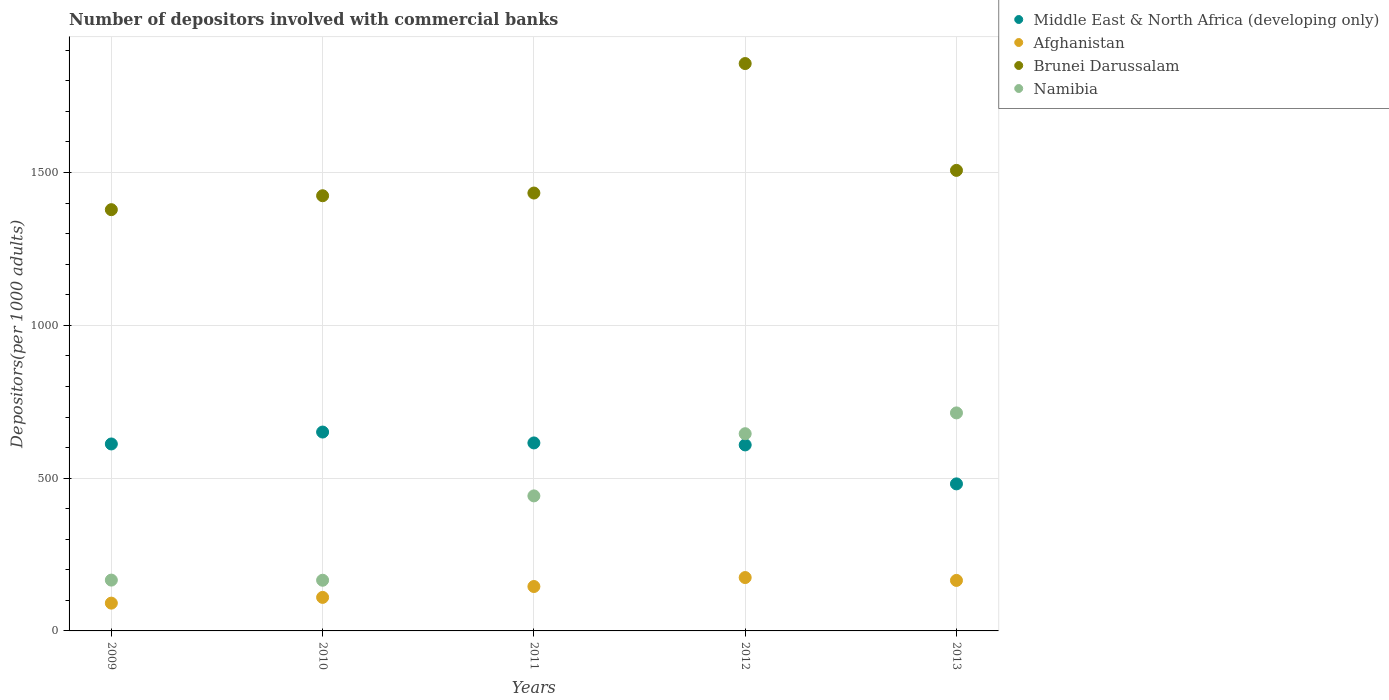How many different coloured dotlines are there?
Offer a very short reply. 4. Is the number of dotlines equal to the number of legend labels?
Ensure brevity in your answer.  Yes. What is the number of depositors involved with commercial banks in Middle East & North Africa (developing only) in 2009?
Your response must be concise. 611.77. Across all years, what is the maximum number of depositors involved with commercial banks in Namibia?
Ensure brevity in your answer.  713.41. Across all years, what is the minimum number of depositors involved with commercial banks in Namibia?
Offer a very short reply. 165.83. In which year was the number of depositors involved with commercial banks in Middle East & North Africa (developing only) maximum?
Offer a terse response. 2010. In which year was the number of depositors involved with commercial banks in Brunei Darussalam minimum?
Give a very brief answer. 2009. What is the total number of depositors involved with commercial banks in Namibia in the graph?
Ensure brevity in your answer.  2132.7. What is the difference between the number of depositors involved with commercial banks in Namibia in 2009 and that in 2012?
Your answer should be very brief. -479.02. What is the difference between the number of depositors involved with commercial banks in Brunei Darussalam in 2011 and the number of depositors involved with commercial banks in Afghanistan in 2012?
Give a very brief answer. 1258.24. What is the average number of depositors involved with commercial banks in Brunei Darussalam per year?
Your answer should be compact. 1519.8. In the year 2013, what is the difference between the number of depositors involved with commercial banks in Brunei Darussalam and number of depositors involved with commercial banks in Afghanistan?
Your response must be concise. 1341.76. In how many years, is the number of depositors involved with commercial banks in Brunei Darussalam greater than 1200?
Your answer should be very brief. 5. What is the ratio of the number of depositors involved with commercial banks in Middle East & North Africa (developing only) in 2009 to that in 2010?
Your answer should be very brief. 0.94. Is the number of depositors involved with commercial banks in Afghanistan in 2009 less than that in 2013?
Your answer should be compact. Yes. Is the difference between the number of depositors involved with commercial banks in Brunei Darussalam in 2012 and 2013 greater than the difference between the number of depositors involved with commercial banks in Afghanistan in 2012 and 2013?
Your answer should be compact. Yes. What is the difference between the highest and the second highest number of depositors involved with commercial banks in Afghanistan?
Your answer should be compact. 9.36. What is the difference between the highest and the lowest number of depositors involved with commercial banks in Namibia?
Ensure brevity in your answer.  547.58. Is it the case that in every year, the sum of the number of depositors involved with commercial banks in Middle East & North Africa (developing only) and number of depositors involved with commercial banks in Namibia  is greater than the sum of number of depositors involved with commercial banks in Brunei Darussalam and number of depositors involved with commercial banks in Afghanistan?
Provide a succinct answer. Yes. Is it the case that in every year, the sum of the number of depositors involved with commercial banks in Namibia and number of depositors involved with commercial banks in Afghanistan  is greater than the number of depositors involved with commercial banks in Brunei Darussalam?
Ensure brevity in your answer.  No. Does the number of depositors involved with commercial banks in Afghanistan monotonically increase over the years?
Your answer should be very brief. No. Is the number of depositors involved with commercial banks in Namibia strictly greater than the number of depositors involved with commercial banks in Middle East & North Africa (developing only) over the years?
Keep it short and to the point. No. Is the number of depositors involved with commercial banks in Middle East & North Africa (developing only) strictly less than the number of depositors involved with commercial banks in Brunei Darussalam over the years?
Provide a short and direct response. Yes. How many years are there in the graph?
Your response must be concise. 5. Are the values on the major ticks of Y-axis written in scientific E-notation?
Offer a very short reply. No. Does the graph contain any zero values?
Offer a terse response. No. Where does the legend appear in the graph?
Offer a very short reply. Top right. How many legend labels are there?
Your response must be concise. 4. What is the title of the graph?
Make the answer very short. Number of depositors involved with commercial banks. Does "St. Vincent and the Grenadines" appear as one of the legend labels in the graph?
Offer a terse response. No. What is the label or title of the Y-axis?
Your response must be concise. Depositors(per 1000 adults). What is the Depositors(per 1000 adults) of Middle East & North Africa (developing only) in 2009?
Provide a succinct answer. 611.77. What is the Depositors(per 1000 adults) of Afghanistan in 2009?
Offer a terse response. 90.91. What is the Depositors(per 1000 adults) of Brunei Darussalam in 2009?
Give a very brief answer. 1378.46. What is the Depositors(per 1000 adults) of Namibia in 2009?
Offer a very short reply. 166.31. What is the Depositors(per 1000 adults) of Middle East & North Africa (developing only) in 2010?
Keep it short and to the point. 650.77. What is the Depositors(per 1000 adults) of Afghanistan in 2010?
Make the answer very short. 109.72. What is the Depositors(per 1000 adults) of Brunei Darussalam in 2010?
Provide a short and direct response. 1424.06. What is the Depositors(per 1000 adults) in Namibia in 2010?
Your response must be concise. 165.83. What is the Depositors(per 1000 adults) of Middle East & North Africa (developing only) in 2011?
Offer a very short reply. 615.16. What is the Depositors(per 1000 adults) of Afghanistan in 2011?
Give a very brief answer. 145.33. What is the Depositors(per 1000 adults) of Brunei Darussalam in 2011?
Ensure brevity in your answer.  1432.88. What is the Depositors(per 1000 adults) of Namibia in 2011?
Make the answer very short. 441.82. What is the Depositors(per 1000 adults) in Middle East & North Africa (developing only) in 2012?
Give a very brief answer. 608.64. What is the Depositors(per 1000 adults) in Afghanistan in 2012?
Your answer should be very brief. 174.63. What is the Depositors(per 1000 adults) of Brunei Darussalam in 2012?
Keep it short and to the point. 1856.6. What is the Depositors(per 1000 adults) of Namibia in 2012?
Your answer should be very brief. 645.33. What is the Depositors(per 1000 adults) of Middle East & North Africa (developing only) in 2013?
Your answer should be compact. 481.17. What is the Depositors(per 1000 adults) in Afghanistan in 2013?
Give a very brief answer. 165.27. What is the Depositors(per 1000 adults) in Brunei Darussalam in 2013?
Provide a short and direct response. 1507.03. What is the Depositors(per 1000 adults) of Namibia in 2013?
Make the answer very short. 713.41. Across all years, what is the maximum Depositors(per 1000 adults) in Middle East & North Africa (developing only)?
Your answer should be very brief. 650.77. Across all years, what is the maximum Depositors(per 1000 adults) of Afghanistan?
Offer a very short reply. 174.63. Across all years, what is the maximum Depositors(per 1000 adults) in Brunei Darussalam?
Provide a succinct answer. 1856.6. Across all years, what is the maximum Depositors(per 1000 adults) of Namibia?
Ensure brevity in your answer.  713.41. Across all years, what is the minimum Depositors(per 1000 adults) in Middle East & North Africa (developing only)?
Offer a terse response. 481.17. Across all years, what is the minimum Depositors(per 1000 adults) of Afghanistan?
Your answer should be very brief. 90.91. Across all years, what is the minimum Depositors(per 1000 adults) of Brunei Darussalam?
Your response must be concise. 1378.46. Across all years, what is the minimum Depositors(per 1000 adults) of Namibia?
Give a very brief answer. 165.83. What is the total Depositors(per 1000 adults) in Middle East & North Africa (developing only) in the graph?
Give a very brief answer. 2967.5. What is the total Depositors(per 1000 adults) of Afghanistan in the graph?
Offer a very short reply. 685.87. What is the total Depositors(per 1000 adults) of Brunei Darussalam in the graph?
Provide a short and direct response. 7599.02. What is the total Depositors(per 1000 adults) of Namibia in the graph?
Your response must be concise. 2132.7. What is the difference between the Depositors(per 1000 adults) of Middle East & North Africa (developing only) in 2009 and that in 2010?
Your answer should be very brief. -39. What is the difference between the Depositors(per 1000 adults) of Afghanistan in 2009 and that in 2010?
Provide a short and direct response. -18.81. What is the difference between the Depositors(per 1000 adults) in Brunei Darussalam in 2009 and that in 2010?
Your response must be concise. -45.61. What is the difference between the Depositors(per 1000 adults) in Namibia in 2009 and that in 2010?
Offer a very short reply. 0.47. What is the difference between the Depositors(per 1000 adults) in Middle East & North Africa (developing only) in 2009 and that in 2011?
Offer a terse response. -3.39. What is the difference between the Depositors(per 1000 adults) in Afghanistan in 2009 and that in 2011?
Provide a succinct answer. -54.42. What is the difference between the Depositors(per 1000 adults) of Brunei Darussalam in 2009 and that in 2011?
Make the answer very short. -54.42. What is the difference between the Depositors(per 1000 adults) in Namibia in 2009 and that in 2011?
Make the answer very short. -275.51. What is the difference between the Depositors(per 1000 adults) of Middle East & North Africa (developing only) in 2009 and that in 2012?
Your answer should be compact. 3.13. What is the difference between the Depositors(per 1000 adults) in Afghanistan in 2009 and that in 2012?
Give a very brief answer. -83.72. What is the difference between the Depositors(per 1000 adults) of Brunei Darussalam in 2009 and that in 2012?
Keep it short and to the point. -478.14. What is the difference between the Depositors(per 1000 adults) of Namibia in 2009 and that in 2012?
Your response must be concise. -479.02. What is the difference between the Depositors(per 1000 adults) in Middle East & North Africa (developing only) in 2009 and that in 2013?
Your answer should be very brief. 130.6. What is the difference between the Depositors(per 1000 adults) of Afghanistan in 2009 and that in 2013?
Offer a very short reply. -74.36. What is the difference between the Depositors(per 1000 adults) in Brunei Darussalam in 2009 and that in 2013?
Your response must be concise. -128.58. What is the difference between the Depositors(per 1000 adults) in Namibia in 2009 and that in 2013?
Your answer should be compact. -547.1. What is the difference between the Depositors(per 1000 adults) of Middle East & North Africa (developing only) in 2010 and that in 2011?
Your answer should be very brief. 35.61. What is the difference between the Depositors(per 1000 adults) in Afghanistan in 2010 and that in 2011?
Your answer should be compact. -35.61. What is the difference between the Depositors(per 1000 adults) of Brunei Darussalam in 2010 and that in 2011?
Keep it short and to the point. -8.82. What is the difference between the Depositors(per 1000 adults) in Namibia in 2010 and that in 2011?
Your response must be concise. -275.99. What is the difference between the Depositors(per 1000 adults) in Middle East & North Africa (developing only) in 2010 and that in 2012?
Your response must be concise. 42.13. What is the difference between the Depositors(per 1000 adults) in Afghanistan in 2010 and that in 2012?
Make the answer very short. -64.91. What is the difference between the Depositors(per 1000 adults) of Brunei Darussalam in 2010 and that in 2012?
Offer a very short reply. -432.53. What is the difference between the Depositors(per 1000 adults) of Namibia in 2010 and that in 2012?
Offer a terse response. -479.5. What is the difference between the Depositors(per 1000 adults) in Middle East & North Africa (developing only) in 2010 and that in 2013?
Provide a short and direct response. 169.6. What is the difference between the Depositors(per 1000 adults) in Afghanistan in 2010 and that in 2013?
Offer a terse response. -55.55. What is the difference between the Depositors(per 1000 adults) in Brunei Darussalam in 2010 and that in 2013?
Keep it short and to the point. -82.97. What is the difference between the Depositors(per 1000 adults) of Namibia in 2010 and that in 2013?
Give a very brief answer. -547.58. What is the difference between the Depositors(per 1000 adults) of Middle East & North Africa (developing only) in 2011 and that in 2012?
Keep it short and to the point. 6.52. What is the difference between the Depositors(per 1000 adults) in Afghanistan in 2011 and that in 2012?
Your answer should be very brief. -29.3. What is the difference between the Depositors(per 1000 adults) of Brunei Darussalam in 2011 and that in 2012?
Your response must be concise. -423.72. What is the difference between the Depositors(per 1000 adults) of Namibia in 2011 and that in 2012?
Provide a succinct answer. -203.51. What is the difference between the Depositors(per 1000 adults) in Middle East & North Africa (developing only) in 2011 and that in 2013?
Give a very brief answer. 133.99. What is the difference between the Depositors(per 1000 adults) of Afghanistan in 2011 and that in 2013?
Ensure brevity in your answer.  -19.94. What is the difference between the Depositors(per 1000 adults) of Brunei Darussalam in 2011 and that in 2013?
Ensure brevity in your answer.  -74.15. What is the difference between the Depositors(per 1000 adults) in Namibia in 2011 and that in 2013?
Your response must be concise. -271.59. What is the difference between the Depositors(per 1000 adults) of Middle East & North Africa (developing only) in 2012 and that in 2013?
Give a very brief answer. 127.47. What is the difference between the Depositors(per 1000 adults) in Afghanistan in 2012 and that in 2013?
Ensure brevity in your answer.  9.36. What is the difference between the Depositors(per 1000 adults) in Brunei Darussalam in 2012 and that in 2013?
Give a very brief answer. 349.56. What is the difference between the Depositors(per 1000 adults) of Namibia in 2012 and that in 2013?
Your answer should be compact. -68.08. What is the difference between the Depositors(per 1000 adults) of Middle East & North Africa (developing only) in 2009 and the Depositors(per 1000 adults) of Afghanistan in 2010?
Make the answer very short. 502.04. What is the difference between the Depositors(per 1000 adults) in Middle East & North Africa (developing only) in 2009 and the Depositors(per 1000 adults) in Brunei Darussalam in 2010?
Give a very brief answer. -812.3. What is the difference between the Depositors(per 1000 adults) of Middle East & North Africa (developing only) in 2009 and the Depositors(per 1000 adults) of Namibia in 2010?
Your answer should be compact. 445.93. What is the difference between the Depositors(per 1000 adults) in Afghanistan in 2009 and the Depositors(per 1000 adults) in Brunei Darussalam in 2010?
Give a very brief answer. -1333.15. What is the difference between the Depositors(per 1000 adults) in Afghanistan in 2009 and the Depositors(per 1000 adults) in Namibia in 2010?
Your answer should be very brief. -74.93. What is the difference between the Depositors(per 1000 adults) in Brunei Darussalam in 2009 and the Depositors(per 1000 adults) in Namibia in 2010?
Provide a succinct answer. 1212.62. What is the difference between the Depositors(per 1000 adults) of Middle East & North Africa (developing only) in 2009 and the Depositors(per 1000 adults) of Afghanistan in 2011?
Provide a short and direct response. 466.44. What is the difference between the Depositors(per 1000 adults) in Middle East & North Africa (developing only) in 2009 and the Depositors(per 1000 adults) in Brunei Darussalam in 2011?
Your answer should be compact. -821.11. What is the difference between the Depositors(per 1000 adults) of Middle East & North Africa (developing only) in 2009 and the Depositors(per 1000 adults) of Namibia in 2011?
Your answer should be very brief. 169.94. What is the difference between the Depositors(per 1000 adults) in Afghanistan in 2009 and the Depositors(per 1000 adults) in Brunei Darussalam in 2011?
Offer a terse response. -1341.97. What is the difference between the Depositors(per 1000 adults) of Afghanistan in 2009 and the Depositors(per 1000 adults) of Namibia in 2011?
Offer a very short reply. -350.91. What is the difference between the Depositors(per 1000 adults) in Brunei Darussalam in 2009 and the Depositors(per 1000 adults) in Namibia in 2011?
Keep it short and to the point. 936.63. What is the difference between the Depositors(per 1000 adults) of Middle East & North Africa (developing only) in 2009 and the Depositors(per 1000 adults) of Afghanistan in 2012?
Provide a succinct answer. 437.13. What is the difference between the Depositors(per 1000 adults) of Middle East & North Africa (developing only) in 2009 and the Depositors(per 1000 adults) of Brunei Darussalam in 2012?
Offer a very short reply. -1244.83. What is the difference between the Depositors(per 1000 adults) of Middle East & North Africa (developing only) in 2009 and the Depositors(per 1000 adults) of Namibia in 2012?
Keep it short and to the point. -33.56. What is the difference between the Depositors(per 1000 adults) of Afghanistan in 2009 and the Depositors(per 1000 adults) of Brunei Darussalam in 2012?
Your answer should be very brief. -1765.69. What is the difference between the Depositors(per 1000 adults) of Afghanistan in 2009 and the Depositors(per 1000 adults) of Namibia in 2012?
Give a very brief answer. -554.42. What is the difference between the Depositors(per 1000 adults) of Brunei Darussalam in 2009 and the Depositors(per 1000 adults) of Namibia in 2012?
Ensure brevity in your answer.  733.13. What is the difference between the Depositors(per 1000 adults) in Middle East & North Africa (developing only) in 2009 and the Depositors(per 1000 adults) in Afghanistan in 2013?
Offer a very short reply. 446.49. What is the difference between the Depositors(per 1000 adults) of Middle East & North Africa (developing only) in 2009 and the Depositors(per 1000 adults) of Brunei Darussalam in 2013?
Provide a short and direct response. -895.27. What is the difference between the Depositors(per 1000 adults) of Middle East & North Africa (developing only) in 2009 and the Depositors(per 1000 adults) of Namibia in 2013?
Offer a very short reply. -101.65. What is the difference between the Depositors(per 1000 adults) of Afghanistan in 2009 and the Depositors(per 1000 adults) of Brunei Darussalam in 2013?
Offer a terse response. -1416.12. What is the difference between the Depositors(per 1000 adults) of Afghanistan in 2009 and the Depositors(per 1000 adults) of Namibia in 2013?
Your answer should be very brief. -622.5. What is the difference between the Depositors(per 1000 adults) of Brunei Darussalam in 2009 and the Depositors(per 1000 adults) of Namibia in 2013?
Ensure brevity in your answer.  665.04. What is the difference between the Depositors(per 1000 adults) in Middle East & North Africa (developing only) in 2010 and the Depositors(per 1000 adults) in Afghanistan in 2011?
Your answer should be very brief. 505.44. What is the difference between the Depositors(per 1000 adults) in Middle East & North Africa (developing only) in 2010 and the Depositors(per 1000 adults) in Brunei Darussalam in 2011?
Your response must be concise. -782.11. What is the difference between the Depositors(per 1000 adults) in Middle East & North Africa (developing only) in 2010 and the Depositors(per 1000 adults) in Namibia in 2011?
Your response must be concise. 208.95. What is the difference between the Depositors(per 1000 adults) of Afghanistan in 2010 and the Depositors(per 1000 adults) of Brunei Darussalam in 2011?
Give a very brief answer. -1323.16. What is the difference between the Depositors(per 1000 adults) in Afghanistan in 2010 and the Depositors(per 1000 adults) in Namibia in 2011?
Keep it short and to the point. -332.1. What is the difference between the Depositors(per 1000 adults) of Brunei Darussalam in 2010 and the Depositors(per 1000 adults) of Namibia in 2011?
Your answer should be very brief. 982.24. What is the difference between the Depositors(per 1000 adults) in Middle East & North Africa (developing only) in 2010 and the Depositors(per 1000 adults) in Afghanistan in 2012?
Give a very brief answer. 476.13. What is the difference between the Depositors(per 1000 adults) in Middle East & North Africa (developing only) in 2010 and the Depositors(per 1000 adults) in Brunei Darussalam in 2012?
Make the answer very short. -1205.83. What is the difference between the Depositors(per 1000 adults) in Middle East & North Africa (developing only) in 2010 and the Depositors(per 1000 adults) in Namibia in 2012?
Give a very brief answer. 5.44. What is the difference between the Depositors(per 1000 adults) of Afghanistan in 2010 and the Depositors(per 1000 adults) of Brunei Darussalam in 2012?
Offer a terse response. -1746.87. What is the difference between the Depositors(per 1000 adults) of Afghanistan in 2010 and the Depositors(per 1000 adults) of Namibia in 2012?
Offer a very short reply. -535.61. What is the difference between the Depositors(per 1000 adults) in Brunei Darussalam in 2010 and the Depositors(per 1000 adults) in Namibia in 2012?
Offer a very short reply. 778.73. What is the difference between the Depositors(per 1000 adults) of Middle East & North Africa (developing only) in 2010 and the Depositors(per 1000 adults) of Afghanistan in 2013?
Make the answer very short. 485.5. What is the difference between the Depositors(per 1000 adults) in Middle East & North Africa (developing only) in 2010 and the Depositors(per 1000 adults) in Brunei Darussalam in 2013?
Provide a short and direct response. -856.27. What is the difference between the Depositors(per 1000 adults) in Middle East & North Africa (developing only) in 2010 and the Depositors(per 1000 adults) in Namibia in 2013?
Make the answer very short. -62.64. What is the difference between the Depositors(per 1000 adults) of Afghanistan in 2010 and the Depositors(per 1000 adults) of Brunei Darussalam in 2013?
Give a very brief answer. -1397.31. What is the difference between the Depositors(per 1000 adults) in Afghanistan in 2010 and the Depositors(per 1000 adults) in Namibia in 2013?
Ensure brevity in your answer.  -603.69. What is the difference between the Depositors(per 1000 adults) in Brunei Darussalam in 2010 and the Depositors(per 1000 adults) in Namibia in 2013?
Offer a terse response. 710.65. What is the difference between the Depositors(per 1000 adults) in Middle East & North Africa (developing only) in 2011 and the Depositors(per 1000 adults) in Afghanistan in 2012?
Give a very brief answer. 440.52. What is the difference between the Depositors(per 1000 adults) of Middle East & North Africa (developing only) in 2011 and the Depositors(per 1000 adults) of Brunei Darussalam in 2012?
Your answer should be compact. -1241.44. What is the difference between the Depositors(per 1000 adults) in Middle East & North Africa (developing only) in 2011 and the Depositors(per 1000 adults) in Namibia in 2012?
Your response must be concise. -30.17. What is the difference between the Depositors(per 1000 adults) in Afghanistan in 2011 and the Depositors(per 1000 adults) in Brunei Darussalam in 2012?
Provide a succinct answer. -1711.27. What is the difference between the Depositors(per 1000 adults) in Afghanistan in 2011 and the Depositors(per 1000 adults) in Namibia in 2012?
Your answer should be compact. -500. What is the difference between the Depositors(per 1000 adults) of Brunei Darussalam in 2011 and the Depositors(per 1000 adults) of Namibia in 2012?
Offer a terse response. 787.55. What is the difference between the Depositors(per 1000 adults) in Middle East & North Africa (developing only) in 2011 and the Depositors(per 1000 adults) in Afghanistan in 2013?
Ensure brevity in your answer.  449.89. What is the difference between the Depositors(per 1000 adults) in Middle East & North Africa (developing only) in 2011 and the Depositors(per 1000 adults) in Brunei Darussalam in 2013?
Provide a short and direct response. -891.88. What is the difference between the Depositors(per 1000 adults) in Middle East & North Africa (developing only) in 2011 and the Depositors(per 1000 adults) in Namibia in 2013?
Your answer should be compact. -98.25. What is the difference between the Depositors(per 1000 adults) of Afghanistan in 2011 and the Depositors(per 1000 adults) of Brunei Darussalam in 2013?
Give a very brief answer. -1361.7. What is the difference between the Depositors(per 1000 adults) of Afghanistan in 2011 and the Depositors(per 1000 adults) of Namibia in 2013?
Your answer should be very brief. -568.08. What is the difference between the Depositors(per 1000 adults) in Brunei Darussalam in 2011 and the Depositors(per 1000 adults) in Namibia in 2013?
Ensure brevity in your answer.  719.47. What is the difference between the Depositors(per 1000 adults) of Middle East & North Africa (developing only) in 2012 and the Depositors(per 1000 adults) of Afghanistan in 2013?
Your answer should be compact. 443.37. What is the difference between the Depositors(per 1000 adults) in Middle East & North Africa (developing only) in 2012 and the Depositors(per 1000 adults) in Brunei Darussalam in 2013?
Keep it short and to the point. -898.39. What is the difference between the Depositors(per 1000 adults) of Middle East & North Africa (developing only) in 2012 and the Depositors(per 1000 adults) of Namibia in 2013?
Give a very brief answer. -104.77. What is the difference between the Depositors(per 1000 adults) of Afghanistan in 2012 and the Depositors(per 1000 adults) of Brunei Darussalam in 2013?
Keep it short and to the point. -1332.4. What is the difference between the Depositors(per 1000 adults) of Afghanistan in 2012 and the Depositors(per 1000 adults) of Namibia in 2013?
Keep it short and to the point. -538.78. What is the difference between the Depositors(per 1000 adults) of Brunei Darussalam in 2012 and the Depositors(per 1000 adults) of Namibia in 2013?
Provide a short and direct response. 1143.18. What is the average Depositors(per 1000 adults) of Middle East & North Africa (developing only) per year?
Ensure brevity in your answer.  593.5. What is the average Depositors(per 1000 adults) of Afghanistan per year?
Offer a terse response. 137.17. What is the average Depositors(per 1000 adults) in Brunei Darussalam per year?
Provide a short and direct response. 1519.8. What is the average Depositors(per 1000 adults) in Namibia per year?
Ensure brevity in your answer.  426.54. In the year 2009, what is the difference between the Depositors(per 1000 adults) of Middle East & North Africa (developing only) and Depositors(per 1000 adults) of Afghanistan?
Your answer should be compact. 520.86. In the year 2009, what is the difference between the Depositors(per 1000 adults) of Middle East & North Africa (developing only) and Depositors(per 1000 adults) of Brunei Darussalam?
Offer a very short reply. -766.69. In the year 2009, what is the difference between the Depositors(per 1000 adults) of Middle East & North Africa (developing only) and Depositors(per 1000 adults) of Namibia?
Make the answer very short. 445.46. In the year 2009, what is the difference between the Depositors(per 1000 adults) of Afghanistan and Depositors(per 1000 adults) of Brunei Darussalam?
Provide a succinct answer. -1287.55. In the year 2009, what is the difference between the Depositors(per 1000 adults) of Afghanistan and Depositors(per 1000 adults) of Namibia?
Offer a terse response. -75.4. In the year 2009, what is the difference between the Depositors(per 1000 adults) in Brunei Darussalam and Depositors(per 1000 adults) in Namibia?
Offer a terse response. 1212.15. In the year 2010, what is the difference between the Depositors(per 1000 adults) in Middle East & North Africa (developing only) and Depositors(per 1000 adults) in Afghanistan?
Your answer should be very brief. 541.04. In the year 2010, what is the difference between the Depositors(per 1000 adults) of Middle East & North Africa (developing only) and Depositors(per 1000 adults) of Brunei Darussalam?
Provide a succinct answer. -773.3. In the year 2010, what is the difference between the Depositors(per 1000 adults) of Middle East & North Africa (developing only) and Depositors(per 1000 adults) of Namibia?
Offer a terse response. 484.93. In the year 2010, what is the difference between the Depositors(per 1000 adults) of Afghanistan and Depositors(per 1000 adults) of Brunei Darussalam?
Offer a terse response. -1314.34. In the year 2010, what is the difference between the Depositors(per 1000 adults) in Afghanistan and Depositors(per 1000 adults) in Namibia?
Your answer should be compact. -56.11. In the year 2010, what is the difference between the Depositors(per 1000 adults) of Brunei Darussalam and Depositors(per 1000 adults) of Namibia?
Provide a succinct answer. 1258.23. In the year 2011, what is the difference between the Depositors(per 1000 adults) in Middle East & North Africa (developing only) and Depositors(per 1000 adults) in Afghanistan?
Offer a terse response. 469.83. In the year 2011, what is the difference between the Depositors(per 1000 adults) of Middle East & North Africa (developing only) and Depositors(per 1000 adults) of Brunei Darussalam?
Give a very brief answer. -817.72. In the year 2011, what is the difference between the Depositors(per 1000 adults) of Middle East & North Africa (developing only) and Depositors(per 1000 adults) of Namibia?
Keep it short and to the point. 173.34. In the year 2011, what is the difference between the Depositors(per 1000 adults) in Afghanistan and Depositors(per 1000 adults) in Brunei Darussalam?
Offer a very short reply. -1287.55. In the year 2011, what is the difference between the Depositors(per 1000 adults) in Afghanistan and Depositors(per 1000 adults) in Namibia?
Keep it short and to the point. -296.49. In the year 2011, what is the difference between the Depositors(per 1000 adults) of Brunei Darussalam and Depositors(per 1000 adults) of Namibia?
Your answer should be compact. 991.06. In the year 2012, what is the difference between the Depositors(per 1000 adults) in Middle East & North Africa (developing only) and Depositors(per 1000 adults) in Afghanistan?
Make the answer very short. 434.01. In the year 2012, what is the difference between the Depositors(per 1000 adults) of Middle East & North Africa (developing only) and Depositors(per 1000 adults) of Brunei Darussalam?
Keep it short and to the point. -1247.96. In the year 2012, what is the difference between the Depositors(per 1000 adults) in Middle East & North Africa (developing only) and Depositors(per 1000 adults) in Namibia?
Your response must be concise. -36.69. In the year 2012, what is the difference between the Depositors(per 1000 adults) of Afghanistan and Depositors(per 1000 adults) of Brunei Darussalam?
Your answer should be compact. -1681.96. In the year 2012, what is the difference between the Depositors(per 1000 adults) of Afghanistan and Depositors(per 1000 adults) of Namibia?
Provide a succinct answer. -470.7. In the year 2012, what is the difference between the Depositors(per 1000 adults) of Brunei Darussalam and Depositors(per 1000 adults) of Namibia?
Provide a short and direct response. 1211.27. In the year 2013, what is the difference between the Depositors(per 1000 adults) of Middle East & North Africa (developing only) and Depositors(per 1000 adults) of Afghanistan?
Provide a succinct answer. 315.9. In the year 2013, what is the difference between the Depositors(per 1000 adults) in Middle East & North Africa (developing only) and Depositors(per 1000 adults) in Brunei Darussalam?
Your response must be concise. -1025.86. In the year 2013, what is the difference between the Depositors(per 1000 adults) in Middle East & North Africa (developing only) and Depositors(per 1000 adults) in Namibia?
Offer a very short reply. -232.24. In the year 2013, what is the difference between the Depositors(per 1000 adults) in Afghanistan and Depositors(per 1000 adults) in Brunei Darussalam?
Offer a very short reply. -1341.76. In the year 2013, what is the difference between the Depositors(per 1000 adults) in Afghanistan and Depositors(per 1000 adults) in Namibia?
Keep it short and to the point. -548.14. In the year 2013, what is the difference between the Depositors(per 1000 adults) in Brunei Darussalam and Depositors(per 1000 adults) in Namibia?
Offer a terse response. 793.62. What is the ratio of the Depositors(per 1000 adults) of Middle East & North Africa (developing only) in 2009 to that in 2010?
Your answer should be very brief. 0.94. What is the ratio of the Depositors(per 1000 adults) in Afghanistan in 2009 to that in 2010?
Give a very brief answer. 0.83. What is the ratio of the Depositors(per 1000 adults) of Brunei Darussalam in 2009 to that in 2010?
Keep it short and to the point. 0.97. What is the ratio of the Depositors(per 1000 adults) in Namibia in 2009 to that in 2010?
Offer a very short reply. 1. What is the ratio of the Depositors(per 1000 adults) of Afghanistan in 2009 to that in 2011?
Keep it short and to the point. 0.63. What is the ratio of the Depositors(per 1000 adults) of Namibia in 2009 to that in 2011?
Your answer should be compact. 0.38. What is the ratio of the Depositors(per 1000 adults) in Middle East & North Africa (developing only) in 2009 to that in 2012?
Provide a succinct answer. 1.01. What is the ratio of the Depositors(per 1000 adults) in Afghanistan in 2009 to that in 2012?
Your answer should be compact. 0.52. What is the ratio of the Depositors(per 1000 adults) of Brunei Darussalam in 2009 to that in 2012?
Offer a very short reply. 0.74. What is the ratio of the Depositors(per 1000 adults) in Namibia in 2009 to that in 2012?
Your answer should be compact. 0.26. What is the ratio of the Depositors(per 1000 adults) of Middle East & North Africa (developing only) in 2009 to that in 2013?
Make the answer very short. 1.27. What is the ratio of the Depositors(per 1000 adults) of Afghanistan in 2009 to that in 2013?
Keep it short and to the point. 0.55. What is the ratio of the Depositors(per 1000 adults) of Brunei Darussalam in 2009 to that in 2013?
Make the answer very short. 0.91. What is the ratio of the Depositors(per 1000 adults) in Namibia in 2009 to that in 2013?
Offer a very short reply. 0.23. What is the ratio of the Depositors(per 1000 adults) of Middle East & North Africa (developing only) in 2010 to that in 2011?
Your answer should be compact. 1.06. What is the ratio of the Depositors(per 1000 adults) of Afghanistan in 2010 to that in 2011?
Your answer should be compact. 0.76. What is the ratio of the Depositors(per 1000 adults) in Brunei Darussalam in 2010 to that in 2011?
Offer a very short reply. 0.99. What is the ratio of the Depositors(per 1000 adults) in Namibia in 2010 to that in 2011?
Your answer should be very brief. 0.38. What is the ratio of the Depositors(per 1000 adults) of Middle East & North Africa (developing only) in 2010 to that in 2012?
Provide a succinct answer. 1.07. What is the ratio of the Depositors(per 1000 adults) in Afghanistan in 2010 to that in 2012?
Give a very brief answer. 0.63. What is the ratio of the Depositors(per 1000 adults) in Brunei Darussalam in 2010 to that in 2012?
Give a very brief answer. 0.77. What is the ratio of the Depositors(per 1000 adults) of Namibia in 2010 to that in 2012?
Provide a succinct answer. 0.26. What is the ratio of the Depositors(per 1000 adults) of Middle East & North Africa (developing only) in 2010 to that in 2013?
Ensure brevity in your answer.  1.35. What is the ratio of the Depositors(per 1000 adults) of Afghanistan in 2010 to that in 2013?
Provide a succinct answer. 0.66. What is the ratio of the Depositors(per 1000 adults) of Brunei Darussalam in 2010 to that in 2013?
Provide a succinct answer. 0.94. What is the ratio of the Depositors(per 1000 adults) of Namibia in 2010 to that in 2013?
Your answer should be compact. 0.23. What is the ratio of the Depositors(per 1000 adults) in Middle East & North Africa (developing only) in 2011 to that in 2012?
Offer a very short reply. 1.01. What is the ratio of the Depositors(per 1000 adults) of Afghanistan in 2011 to that in 2012?
Offer a terse response. 0.83. What is the ratio of the Depositors(per 1000 adults) in Brunei Darussalam in 2011 to that in 2012?
Offer a terse response. 0.77. What is the ratio of the Depositors(per 1000 adults) of Namibia in 2011 to that in 2012?
Make the answer very short. 0.68. What is the ratio of the Depositors(per 1000 adults) of Middle East & North Africa (developing only) in 2011 to that in 2013?
Ensure brevity in your answer.  1.28. What is the ratio of the Depositors(per 1000 adults) in Afghanistan in 2011 to that in 2013?
Make the answer very short. 0.88. What is the ratio of the Depositors(per 1000 adults) in Brunei Darussalam in 2011 to that in 2013?
Your answer should be compact. 0.95. What is the ratio of the Depositors(per 1000 adults) in Namibia in 2011 to that in 2013?
Give a very brief answer. 0.62. What is the ratio of the Depositors(per 1000 adults) of Middle East & North Africa (developing only) in 2012 to that in 2013?
Provide a succinct answer. 1.26. What is the ratio of the Depositors(per 1000 adults) of Afghanistan in 2012 to that in 2013?
Give a very brief answer. 1.06. What is the ratio of the Depositors(per 1000 adults) in Brunei Darussalam in 2012 to that in 2013?
Offer a very short reply. 1.23. What is the ratio of the Depositors(per 1000 adults) in Namibia in 2012 to that in 2013?
Your response must be concise. 0.9. What is the difference between the highest and the second highest Depositors(per 1000 adults) in Middle East & North Africa (developing only)?
Offer a very short reply. 35.61. What is the difference between the highest and the second highest Depositors(per 1000 adults) in Afghanistan?
Your response must be concise. 9.36. What is the difference between the highest and the second highest Depositors(per 1000 adults) of Brunei Darussalam?
Your answer should be compact. 349.56. What is the difference between the highest and the second highest Depositors(per 1000 adults) in Namibia?
Offer a terse response. 68.08. What is the difference between the highest and the lowest Depositors(per 1000 adults) of Middle East & North Africa (developing only)?
Provide a succinct answer. 169.6. What is the difference between the highest and the lowest Depositors(per 1000 adults) of Afghanistan?
Offer a very short reply. 83.72. What is the difference between the highest and the lowest Depositors(per 1000 adults) in Brunei Darussalam?
Keep it short and to the point. 478.14. What is the difference between the highest and the lowest Depositors(per 1000 adults) in Namibia?
Ensure brevity in your answer.  547.58. 